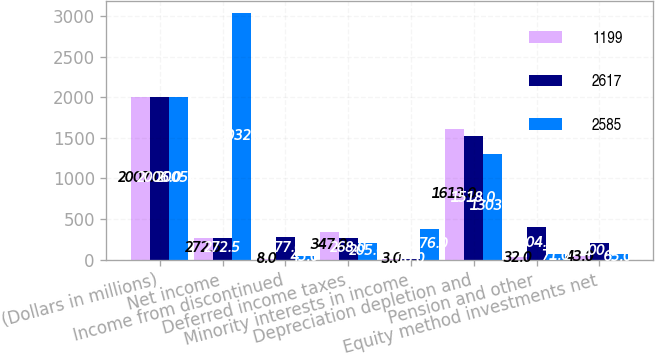Convert chart to OTSL. <chart><loc_0><loc_0><loc_500><loc_500><stacked_bar_chart><ecel><fcel>(Dollars in millions)<fcel>Net income<fcel>Income from discontinued<fcel>Deferred income taxes<fcel>Minority interests in income<fcel>Depreciation depletion and<fcel>Pension and other<fcel>Equity method investments net<nl><fcel>1199<fcel>2007<fcel>272.5<fcel>8<fcel>347<fcel>3<fcel>1613<fcel>32<fcel>43<nl><fcel>2617<fcel>2006<fcel>272.5<fcel>277<fcel>268<fcel>10<fcel>1518<fcel>404<fcel>200<nl><fcel>2585<fcel>2005<fcel>3032<fcel>45<fcel>205<fcel>376<fcel>1303<fcel>71<fcel>65<nl></chart> 